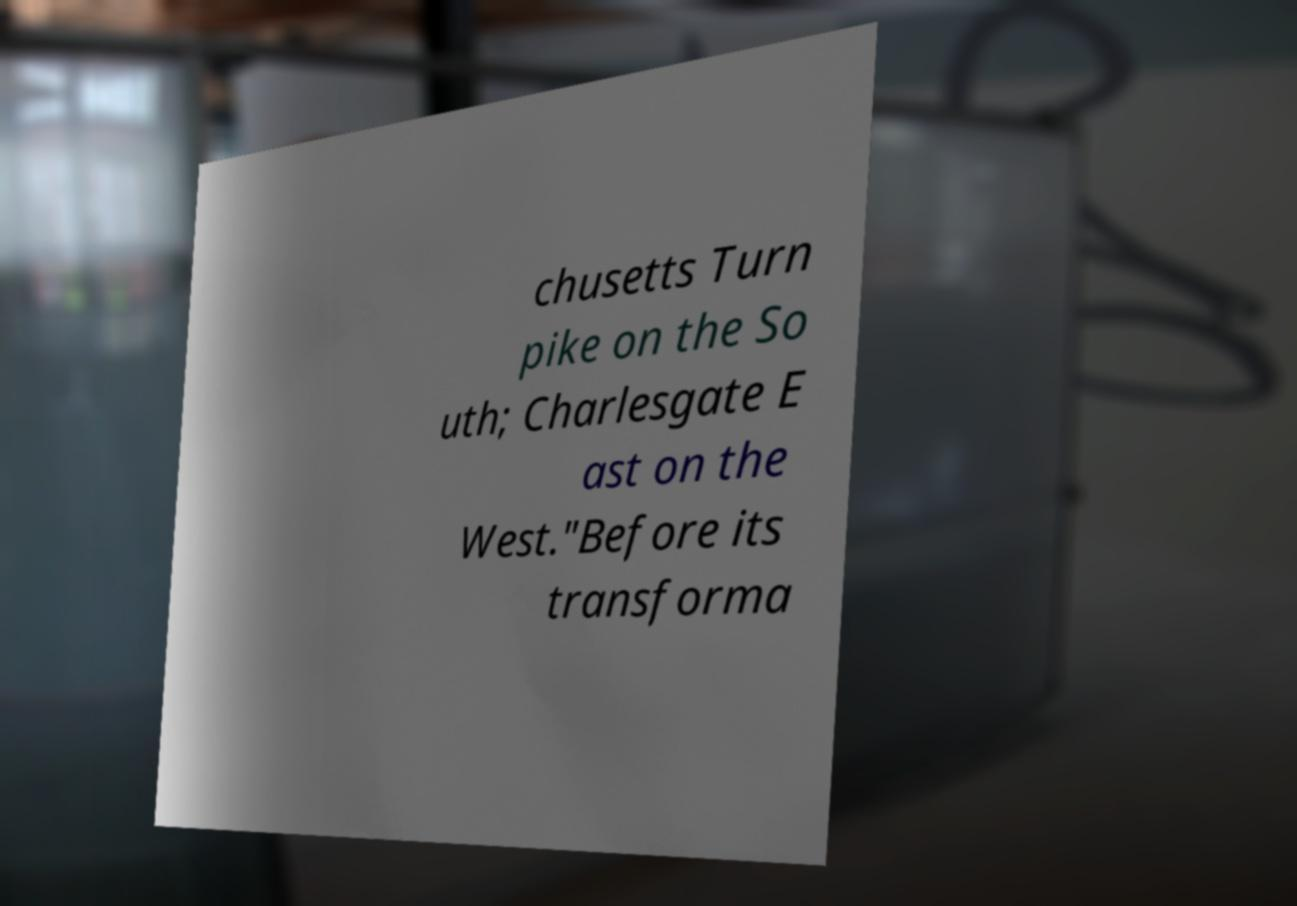Can you read and provide the text displayed in the image?This photo seems to have some interesting text. Can you extract and type it out for me? chusetts Turn pike on the So uth; Charlesgate E ast on the West."Before its transforma 